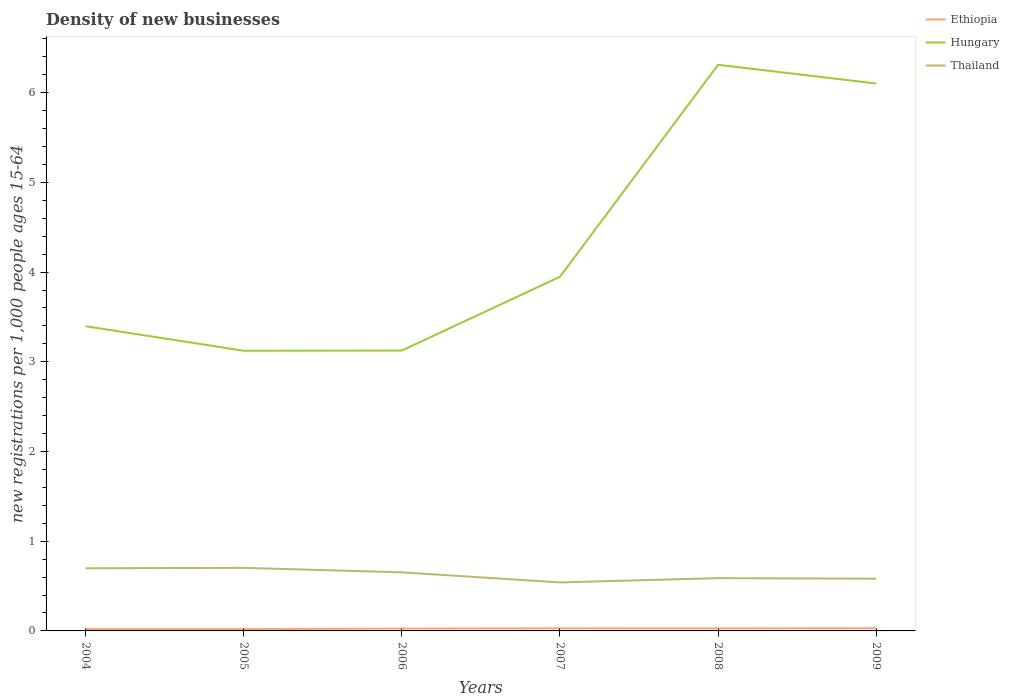Is the number of lines equal to the number of legend labels?
Your response must be concise. Yes. Across all years, what is the maximum number of new registrations in Ethiopia?
Ensure brevity in your answer.  0.02. In which year was the number of new registrations in Hungary maximum?
Provide a short and direct response. 2005. What is the total number of new registrations in Thailand in the graph?
Provide a succinct answer. 0.16. What is the difference between the highest and the second highest number of new registrations in Hungary?
Keep it short and to the point. 3.19. What is the difference between the highest and the lowest number of new registrations in Ethiopia?
Your answer should be very brief. 4. What is the difference between two consecutive major ticks on the Y-axis?
Your answer should be compact. 1. Where does the legend appear in the graph?
Make the answer very short. Top right. What is the title of the graph?
Offer a terse response. Density of new businesses. Does "Luxembourg" appear as one of the legend labels in the graph?
Give a very brief answer. No. What is the label or title of the Y-axis?
Your answer should be compact. New registrations per 1,0 people ages 15-64. What is the new registrations per 1,000 people ages 15-64 of Ethiopia in 2004?
Your answer should be very brief. 0.02. What is the new registrations per 1,000 people ages 15-64 of Hungary in 2004?
Give a very brief answer. 3.4. What is the new registrations per 1,000 people ages 15-64 in Thailand in 2004?
Offer a terse response. 0.7. What is the new registrations per 1,000 people ages 15-64 of Ethiopia in 2005?
Provide a short and direct response. 0.02. What is the new registrations per 1,000 people ages 15-64 of Hungary in 2005?
Provide a succinct answer. 3.12. What is the new registrations per 1,000 people ages 15-64 of Thailand in 2005?
Offer a very short reply. 0.7. What is the new registrations per 1,000 people ages 15-64 of Ethiopia in 2006?
Ensure brevity in your answer.  0.03. What is the new registrations per 1,000 people ages 15-64 in Hungary in 2006?
Give a very brief answer. 3.13. What is the new registrations per 1,000 people ages 15-64 in Thailand in 2006?
Your answer should be very brief. 0.65. What is the new registrations per 1,000 people ages 15-64 of Ethiopia in 2007?
Ensure brevity in your answer.  0.03. What is the new registrations per 1,000 people ages 15-64 of Hungary in 2007?
Give a very brief answer. 3.95. What is the new registrations per 1,000 people ages 15-64 in Thailand in 2007?
Your answer should be compact. 0.54. What is the new registrations per 1,000 people ages 15-64 in Ethiopia in 2008?
Your answer should be very brief. 0.03. What is the new registrations per 1,000 people ages 15-64 of Hungary in 2008?
Ensure brevity in your answer.  6.31. What is the new registrations per 1,000 people ages 15-64 in Thailand in 2008?
Your answer should be compact. 0.59. What is the new registrations per 1,000 people ages 15-64 in Ethiopia in 2009?
Provide a short and direct response. 0.03. What is the new registrations per 1,000 people ages 15-64 in Hungary in 2009?
Provide a succinct answer. 6.1. What is the new registrations per 1,000 people ages 15-64 in Thailand in 2009?
Your answer should be compact. 0.58. Across all years, what is the maximum new registrations per 1,000 people ages 15-64 in Hungary?
Your answer should be compact. 6.31. Across all years, what is the maximum new registrations per 1,000 people ages 15-64 of Thailand?
Offer a very short reply. 0.7. Across all years, what is the minimum new registrations per 1,000 people ages 15-64 in Ethiopia?
Provide a succinct answer. 0.02. Across all years, what is the minimum new registrations per 1,000 people ages 15-64 of Hungary?
Your answer should be very brief. 3.12. Across all years, what is the minimum new registrations per 1,000 people ages 15-64 of Thailand?
Provide a short and direct response. 0.54. What is the total new registrations per 1,000 people ages 15-64 in Ethiopia in the graph?
Ensure brevity in your answer.  0.15. What is the total new registrations per 1,000 people ages 15-64 in Hungary in the graph?
Your answer should be very brief. 26.01. What is the total new registrations per 1,000 people ages 15-64 of Thailand in the graph?
Your response must be concise. 3.77. What is the difference between the new registrations per 1,000 people ages 15-64 in Ethiopia in 2004 and that in 2005?
Your answer should be very brief. -0. What is the difference between the new registrations per 1,000 people ages 15-64 of Hungary in 2004 and that in 2005?
Keep it short and to the point. 0.27. What is the difference between the new registrations per 1,000 people ages 15-64 of Thailand in 2004 and that in 2005?
Provide a short and direct response. -0. What is the difference between the new registrations per 1,000 people ages 15-64 of Ethiopia in 2004 and that in 2006?
Give a very brief answer. -0.01. What is the difference between the new registrations per 1,000 people ages 15-64 in Hungary in 2004 and that in 2006?
Your answer should be very brief. 0.27. What is the difference between the new registrations per 1,000 people ages 15-64 in Thailand in 2004 and that in 2006?
Offer a very short reply. 0.05. What is the difference between the new registrations per 1,000 people ages 15-64 of Ethiopia in 2004 and that in 2007?
Keep it short and to the point. -0.01. What is the difference between the new registrations per 1,000 people ages 15-64 of Hungary in 2004 and that in 2007?
Ensure brevity in your answer.  -0.55. What is the difference between the new registrations per 1,000 people ages 15-64 in Thailand in 2004 and that in 2007?
Your response must be concise. 0.16. What is the difference between the new registrations per 1,000 people ages 15-64 in Ethiopia in 2004 and that in 2008?
Your answer should be compact. -0.01. What is the difference between the new registrations per 1,000 people ages 15-64 of Hungary in 2004 and that in 2008?
Give a very brief answer. -2.91. What is the difference between the new registrations per 1,000 people ages 15-64 of Thailand in 2004 and that in 2008?
Provide a succinct answer. 0.11. What is the difference between the new registrations per 1,000 people ages 15-64 in Ethiopia in 2004 and that in 2009?
Provide a short and direct response. -0.01. What is the difference between the new registrations per 1,000 people ages 15-64 of Hungary in 2004 and that in 2009?
Your response must be concise. -2.71. What is the difference between the new registrations per 1,000 people ages 15-64 in Thailand in 2004 and that in 2009?
Offer a very short reply. 0.12. What is the difference between the new registrations per 1,000 people ages 15-64 of Ethiopia in 2005 and that in 2006?
Offer a very short reply. -0.01. What is the difference between the new registrations per 1,000 people ages 15-64 in Hungary in 2005 and that in 2006?
Provide a succinct answer. -0. What is the difference between the new registrations per 1,000 people ages 15-64 in Thailand in 2005 and that in 2006?
Make the answer very short. 0.05. What is the difference between the new registrations per 1,000 people ages 15-64 in Ethiopia in 2005 and that in 2007?
Your answer should be very brief. -0.01. What is the difference between the new registrations per 1,000 people ages 15-64 of Hungary in 2005 and that in 2007?
Keep it short and to the point. -0.82. What is the difference between the new registrations per 1,000 people ages 15-64 in Thailand in 2005 and that in 2007?
Give a very brief answer. 0.16. What is the difference between the new registrations per 1,000 people ages 15-64 of Ethiopia in 2005 and that in 2008?
Give a very brief answer. -0.01. What is the difference between the new registrations per 1,000 people ages 15-64 in Hungary in 2005 and that in 2008?
Offer a very short reply. -3.19. What is the difference between the new registrations per 1,000 people ages 15-64 of Thailand in 2005 and that in 2008?
Ensure brevity in your answer.  0.11. What is the difference between the new registrations per 1,000 people ages 15-64 in Ethiopia in 2005 and that in 2009?
Your answer should be very brief. -0.01. What is the difference between the new registrations per 1,000 people ages 15-64 of Hungary in 2005 and that in 2009?
Offer a terse response. -2.98. What is the difference between the new registrations per 1,000 people ages 15-64 in Thailand in 2005 and that in 2009?
Ensure brevity in your answer.  0.12. What is the difference between the new registrations per 1,000 people ages 15-64 of Ethiopia in 2006 and that in 2007?
Keep it short and to the point. -0. What is the difference between the new registrations per 1,000 people ages 15-64 in Hungary in 2006 and that in 2007?
Give a very brief answer. -0.82. What is the difference between the new registrations per 1,000 people ages 15-64 of Thailand in 2006 and that in 2007?
Your response must be concise. 0.11. What is the difference between the new registrations per 1,000 people ages 15-64 of Ethiopia in 2006 and that in 2008?
Give a very brief answer. -0. What is the difference between the new registrations per 1,000 people ages 15-64 of Hungary in 2006 and that in 2008?
Make the answer very short. -3.19. What is the difference between the new registrations per 1,000 people ages 15-64 of Thailand in 2006 and that in 2008?
Keep it short and to the point. 0.06. What is the difference between the new registrations per 1,000 people ages 15-64 of Ethiopia in 2006 and that in 2009?
Your answer should be compact. -0. What is the difference between the new registrations per 1,000 people ages 15-64 of Hungary in 2006 and that in 2009?
Offer a terse response. -2.98. What is the difference between the new registrations per 1,000 people ages 15-64 in Thailand in 2006 and that in 2009?
Your answer should be compact. 0.07. What is the difference between the new registrations per 1,000 people ages 15-64 in Ethiopia in 2007 and that in 2008?
Your answer should be compact. 0. What is the difference between the new registrations per 1,000 people ages 15-64 of Hungary in 2007 and that in 2008?
Your response must be concise. -2.36. What is the difference between the new registrations per 1,000 people ages 15-64 of Thailand in 2007 and that in 2008?
Give a very brief answer. -0.05. What is the difference between the new registrations per 1,000 people ages 15-64 of Ethiopia in 2007 and that in 2009?
Offer a very short reply. -0. What is the difference between the new registrations per 1,000 people ages 15-64 in Hungary in 2007 and that in 2009?
Ensure brevity in your answer.  -2.15. What is the difference between the new registrations per 1,000 people ages 15-64 in Thailand in 2007 and that in 2009?
Your answer should be compact. -0.04. What is the difference between the new registrations per 1,000 people ages 15-64 in Ethiopia in 2008 and that in 2009?
Keep it short and to the point. -0. What is the difference between the new registrations per 1,000 people ages 15-64 in Hungary in 2008 and that in 2009?
Your answer should be very brief. 0.21. What is the difference between the new registrations per 1,000 people ages 15-64 of Thailand in 2008 and that in 2009?
Your response must be concise. 0.01. What is the difference between the new registrations per 1,000 people ages 15-64 in Ethiopia in 2004 and the new registrations per 1,000 people ages 15-64 in Hungary in 2005?
Provide a short and direct response. -3.1. What is the difference between the new registrations per 1,000 people ages 15-64 of Ethiopia in 2004 and the new registrations per 1,000 people ages 15-64 of Thailand in 2005?
Offer a very short reply. -0.68. What is the difference between the new registrations per 1,000 people ages 15-64 of Hungary in 2004 and the new registrations per 1,000 people ages 15-64 of Thailand in 2005?
Your response must be concise. 2.69. What is the difference between the new registrations per 1,000 people ages 15-64 of Ethiopia in 2004 and the new registrations per 1,000 people ages 15-64 of Hungary in 2006?
Provide a succinct answer. -3.11. What is the difference between the new registrations per 1,000 people ages 15-64 in Ethiopia in 2004 and the new registrations per 1,000 people ages 15-64 in Thailand in 2006?
Your answer should be very brief. -0.63. What is the difference between the new registrations per 1,000 people ages 15-64 of Hungary in 2004 and the new registrations per 1,000 people ages 15-64 of Thailand in 2006?
Your answer should be compact. 2.74. What is the difference between the new registrations per 1,000 people ages 15-64 in Ethiopia in 2004 and the new registrations per 1,000 people ages 15-64 in Hungary in 2007?
Provide a succinct answer. -3.93. What is the difference between the new registrations per 1,000 people ages 15-64 in Ethiopia in 2004 and the new registrations per 1,000 people ages 15-64 in Thailand in 2007?
Your answer should be very brief. -0.52. What is the difference between the new registrations per 1,000 people ages 15-64 in Hungary in 2004 and the new registrations per 1,000 people ages 15-64 in Thailand in 2007?
Your answer should be very brief. 2.86. What is the difference between the new registrations per 1,000 people ages 15-64 of Ethiopia in 2004 and the new registrations per 1,000 people ages 15-64 of Hungary in 2008?
Ensure brevity in your answer.  -6.29. What is the difference between the new registrations per 1,000 people ages 15-64 of Ethiopia in 2004 and the new registrations per 1,000 people ages 15-64 of Thailand in 2008?
Offer a very short reply. -0.57. What is the difference between the new registrations per 1,000 people ages 15-64 in Hungary in 2004 and the new registrations per 1,000 people ages 15-64 in Thailand in 2008?
Your response must be concise. 2.81. What is the difference between the new registrations per 1,000 people ages 15-64 in Ethiopia in 2004 and the new registrations per 1,000 people ages 15-64 in Hungary in 2009?
Give a very brief answer. -6.08. What is the difference between the new registrations per 1,000 people ages 15-64 in Ethiopia in 2004 and the new registrations per 1,000 people ages 15-64 in Thailand in 2009?
Give a very brief answer. -0.56. What is the difference between the new registrations per 1,000 people ages 15-64 in Hungary in 2004 and the new registrations per 1,000 people ages 15-64 in Thailand in 2009?
Give a very brief answer. 2.81. What is the difference between the new registrations per 1,000 people ages 15-64 in Ethiopia in 2005 and the new registrations per 1,000 people ages 15-64 in Hungary in 2006?
Offer a very short reply. -3.11. What is the difference between the new registrations per 1,000 people ages 15-64 of Ethiopia in 2005 and the new registrations per 1,000 people ages 15-64 of Thailand in 2006?
Your response must be concise. -0.63. What is the difference between the new registrations per 1,000 people ages 15-64 in Hungary in 2005 and the new registrations per 1,000 people ages 15-64 in Thailand in 2006?
Provide a short and direct response. 2.47. What is the difference between the new registrations per 1,000 people ages 15-64 in Ethiopia in 2005 and the new registrations per 1,000 people ages 15-64 in Hungary in 2007?
Provide a short and direct response. -3.93. What is the difference between the new registrations per 1,000 people ages 15-64 of Ethiopia in 2005 and the new registrations per 1,000 people ages 15-64 of Thailand in 2007?
Ensure brevity in your answer.  -0.52. What is the difference between the new registrations per 1,000 people ages 15-64 in Hungary in 2005 and the new registrations per 1,000 people ages 15-64 in Thailand in 2007?
Give a very brief answer. 2.58. What is the difference between the new registrations per 1,000 people ages 15-64 in Ethiopia in 2005 and the new registrations per 1,000 people ages 15-64 in Hungary in 2008?
Ensure brevity in your answer.  -6.29. What is the difference between the new registrations per 1,000 people ages 15-64 of Ethiopia in 2005 and the new registrations per 1,000 people ages 15-64 of Thailand in 2008?
Offer a very short reply. -0.57. What is the difference between the new registrations per 1,000 people ages 15-64 of Hungary in 2005 and the new registrations per 1,000 people ages 15-64 of Thailand in 2008?
Make the answer very short. 2.54. What is the difference between the new registrations per 1,000 people ages 15-64 of Ethiopia in 2005 and the new registrations per 1,000 people ages 15-64 of Hungary in 2009?
Keep it short and to the point. -6.08. What is the difference between the new registrations per 1,000 people ages 15-64 of Ethiopia in 2005 and the new registrations per 1,000 people ages 15-64 of Thailand in 2009?
Give a very brief answer. -0.56. What is the difference between the new registrations per 1,000 people ages 15-64 of Hungary in 2005 and the new registrations per 1,000 people ages 15-64 of Thailand in 2009?
Offer a terse response. 2.54. What is the difference between the new registrations per 1,000 people ages 15-64 in Ethiopia in 2006 and the new registrations per 1,000 people ages 15-64 in Hungary in 2007?
Your answer should be compact. -3.92. What is the difference between the new registrations per 1,000 people ages 15-64 of Ethiopia in 2006 and the new registrations per 1,000 people ages 15-64 of Thailand in 2007?
Your answer should be very brief. -0.51. What is the difference between the new registrations per 1,000 people ages 15-64 of Hungary in 2006 and the new registrations per 1,000 people ages 15-64 of Thailand in 2007?
Offer a very short reply. 2.58. What is the difference between the new registrations per 1,000 people ages 15-64 of Ethiopia in 2006 and the new registrations per 1,000 people ages 15-64 of Hungary in 2008?
Your response must be concise. -6.29. What is the difference between the new registrations per 1,000 people ages 15-64 in Ethiopia in 2006 and the new registrations per 1,000 people ages 15-64 in Thailand in 2008?
Your response must be concise. -0.56. What is the difference between the new registrations per 1,000 people ages 15-64 in Hungary in 2006 and the new registrations per 1,000 people ages 15-64 in Thailand in 2008?
Ensure brevity in your answer.  2.54. What is the difference between the new registrations per 1,000 people ages 15-64 in Ethiopia in 2006 and the new registrations per 1,000 people ages 15-64 in Hungary in 2009?
Keep it short and to the point. -6.08. What is the difference between the new registrations per 1,000 people ages 15-64 in Ethiopia in 2006 and the new registrations per 1,000 people ages 15-64 in Thailand in 2009?
Make the answer very short. -0.56. What is the difference between the new registrations per 1,000 people ages 15-64 in Hungary in 2006 and the new registrations per 1,000 people ages 15-64 in Thailand in 2009?
Give a very brief answer. 2.54. What is the difference between the new registrations per 1,000 people ages 15-64 of Ethiopia in 2007 and the new registrations per 1,000 people ages 15-64 of Hungary in 2008?
Your response must be concise. -6.28. What is the difference between the new registrations per 1,000 people ages 15-64 of Ethiopia in 2007 and the new registrations per 1,000 people ages 15-64 of Thailand in 2008?
Offer a terse response. -0.56. What is the difference between the new registrations per 1,000 people ages 15-64 in Hungary in 2007 and the new registrations per 1,000 people ages 15-64 in Thailand in 2008?
Give a very brief answer. 3.36. What is the difference between the new registrations per 1,000 people ages 15-64 of Ethiopia in 2007 and the new registrations per 1,000 people ages 15-64 of Hungary in 2009?
Ensure brevity in your answer.  -6.07. What is the difference between the new registrations per 1,000 people ages 15-64 of Ethiopia in 2007 and the new registrations per 1,000 people ages 15-64 of Thailand in 2009?
Provide a short and direct response. -0.55. What is the difference between the new registrations per 1,000 people ages 15-64 of Hungary in 2007 and the new registrations per 1,000 people ages 15-64 of Thailand in 2009?
Your response must be concise. 3.37. What is the difference between the new registrations per 1,000 people ages 15-64 in Ethiopia in 2008 and the new registrations per 1,000 people ages 15-64 in Hungary in 2009?
Your answer should be compact. -6.07. What is the difference between the new registrations per 1,000 people ages 15-64 in Ethiopia in 2008 and the new registrations per 1,000 people ages 15-64 in Thailand in 2009?
Give a very brief answer. -0.55. What is the difference between the new registrations per 1,000 people ages 15-64 of Hungary in 2008 and the new registrations per 1,000 people ages 15-64 of Thailand in 2009?
Give a very brief answer. 5.73. What is the average new registrations per 1,000 people ages 15-64 in Ethiopia per year?
Make the answer very short. 0.03. What is the average new registrations per 1,000 people ages 15-64 in Hungary per year?
Keep it short and to the point. 4.33. What is the average new registrations per 1,000 people ages 15-64 in Thailand per year?
Provide a short and direct response. 0.63. In the year 2004, what is the difference between the new registrations per 1,000 people ages 15-64 in Ethiopia and new registrations per 1,000 people ages 15-64 in Hungary?
Provide a short and direct response. -3.38. In the year 2004, what is the difference between the new registrations per 1,000 people ages 15-64 in Ethiopia and new registrations per 1,000 people ages 15-64 in Thailand?
Provide a short and direct response. -0.68. In the year 2004, what is the difference between the new registrations per 1,000 people ages 15-64 of Hungary and new registrations per 1,000 people ages 15-64 of Thailand?
Provide a short and direct response. 2.7. In the year 2005, what is the difference between the new registrations per 1,000 people ages 15-64 of Ethiopia and new registrations per 1,000 people ages 15-64 of Hungary?
Ensure brevity in your answer.  -3.1. In the year 2005, what is the difference between the new registrations per 1,000 people ages 15-64 of Ethiopia and new registrations per 1,000 people ages 15-64 of Thailand?
Keep it short and to the point. -0.68. In the year 2005, what is the difference between the new registrations per 1,000 people ages 15-64 of Hungary and new registrations per 1,000 people ages 15-64 of Thailand?
Your answer should be compact. 2.42. In the year 2006, what is the difference between the new registrations per 1,000 people ages 15-64 in Ethiopia and new registrations per 1,000 people ages 15-64 in Hungary?
Provide a short and direct response. -3.1. In the year 2006, what is the difference between the new registrations per 1,000 people ages 15-64 of Ethiopia and new registrations per 1,000 people ages 15-64 of Thailand?
Provide a succinct answer. -0.63. In the year 2006, what is the difference between the new registrations per 1,000 people ages 15-64 of Hungary and new registrations per 1,000 people ages 15-64 of Thailand?
Your response must be concise. 2.47. In the year 2007, what is the difference between the new registrations per 1,000 people ages 15-64 of Ethiopia and new registrations per 1,000 people ages 15-64 of Hungary?
Your answer should be compact. -3.92. In the year 2007, what is the difference between the new registrations per 1,000 people ages 15-64 in Ethiopia and new registrations per 1,000 people ages 15-64 in Thailand?
Provide a succinct answer. -0.51. In the year 2007, what is the difference between the new registrations per 1,000 people ages 15-64 in Hungary and new registrations per 1,000 people ages 15-64 in Thailand?
Your answer should be compact. 3.41. In the year 2008, what is the difference between the new registrations per 1,000 people ages 15-64 in Ethiopia and new registrations per 1,000 people ages 15-64 in Hungary?
Offer a very short reply. -6.28. In the year 2008, what is the difference between the new registrations per 1,000 people ages 15-64 of Ethiopia and new registrations per 1,000 people ages 15-64 of Thailand?
Make the answer very short. -0.56. In the year 2008, what is the difference between the new registrations per 1,000 people ages 15-64 in Hungary and new registrations per 1,000 people ages 15-64 in Thailand?
Provide a short and direct response. 5.72. In the year 2009, what is the difference between the new registrations per 1,000 people ages 15-64 in Ethiopia and new registrations per 1,000 people ages 15-64 in Hungary?
Make the answer very short. -6.07. In the year 2009, what is the difference between the new registrations per 1,000 people ages 15-64 in Ethiopia and new registrations per 1,000 people ages 15-64 in Thailand?
Make the answer very short. -0.55. In the year 2009, what is the difference between the new registrations per 1,000 people ages 15-64 of Hungary and new registrations per 1,000 people ages 15-64 of Thailand?
Offer a very short reply. 5.52. What is the ratio of the new registrations per 1,000 people ages 15-64 of Hungary in 2004 to that in 2005?
Your answer should be very brief. 1.09. What is the ratio of the new registrations per 1,000 people ages 15-64 of Thailand in 2004 to that in 2005?
Ensure brevity in your answer.  0.99. What is the ratio of the new registrations per 1,000 people ages 15-64 in Ethiopia in 2004 to that in 2006?
Give a very brief answer. 0.77. What is the ratio of the new registrations per 1,000 people ages 15-64 of Hungary in 2004 to that in 2006?
Offer a very short reply. 1.09. What is the ratio of the new registrations per 1,000 people ages 15-64 in Thailand in 2004 to that in 2006?
Provide a short and direct response. 1.07. What is the ratio of the new registrations per 1,000 people ages 15-64 in Ethiopia in 2004 to that in 2007?
Provide a succinct answer. 0.69. What is the ratio of the new registrations per 1,000 people ages 15-64 of Hungary in 2004 to that in 2007?
Offer a terse response. 0.86. What is the ratio of the new registrations per 1,000 people ages 15-64 in Thailand in 2004 to that in 2007?
Your answer should be compact. 1.29. What is the ratio of the new registrations per 1,000 people ages 15-64 of Ethiopia in 2004 to that in 2008?
Offer a very short reply. 0.71. What is the ratio of the new registrations per 1,000 people ages 15-64 in Hungary in 2004 to that in 2008?
Provide a succinct answer. 0.54. What is the ratio of the new registrations per 1,000 people ages 15-64 in Thailand in 2004 to that in 2008?
Offer a very short reply. 1.19. What is the ratio of the new registrations per 1,000 people ages 15-64 in Ethiopia in 2004 to that in 2009?
Your answer should be very brief. 0.67. What is the ratio of the new registrations per 1,000 people ages 15-64 in Hungary in 2004 to that in 2009?
Provide a succinct answer. 0.56. What is the ratio of the new registrations per 1,000 people ages 15-64 in Thailand in 2004 to that in 2009?
Offer a very short reply. 1.2. What is the ratio of the new registrations per 1,000 people ages 15-64 in Ethiopia in 2005 to that in 2006?
Offer a terse response. 0.77. What is the ratio of the new registrations per 1,000 people ages 15-64 of Hungary in 2005 to that in 2006?
Provide a short and direct response. 1. What is the ratio of the new registrations per 1,000 people ages 15-64 of Thailand in 2005 to that in 2006?
Offer a terse response. 1.08. What is the ratio of the new registrations per 1,000 people ages 15-64 of Ethiopia in 2005 to that in 2007?
Offer a very short reply. 0.69. What is the ratio of the new registrations per 1,000 people ages 15-64 of Hungary in 2005 to that in 2007?
Your response must be concise. 0.79. What is the ratio of the new registrations per 1,000 people ages 15-64 of Thailand in 2005 to that in 2007?
Provide a succinct answer. 1.3. What is the ratio of the new registrations per 1,000 people ages 15-64 of Ethiopia in 2005 to that in 2008?
Provide a succinct answer. 0.71. What is the ratio of the new registrations per 1,000 people ages 15-64 in Hungary in 2005 to that in 2008?
Your answer should be very brief. 0.49. What is the ratio of the new registrations per 1,000 people ages 15-64 of Thailand in 2005 to that in 2008?
Offer a terse response. 1.2. What is the ratio of the new registrations per 1,000 people ages 15-64 in Ethiopia in 2005 to that in 2009?
Ensure brevity in your answer.  0.67. What is the ratio of the new registrations per 1,000 people ages 15-64 in Hungary in 2005 to that in 2009?
Provide a succinct answer. 0.51. What is the ratio of the new registrations per 1,000 people ages 15-64 of Thailand in 2005 to that in 2009?
Your answer should be compact. 1.21. What is the ratio of the new registrations per 1,000 people ages 15-64 of Ethiopia in 2006 to that in 2007?
Ensure brevity in your answer.  0.9. What is the ratio of the new registrations per 1,000 people ages 15-64 of Hungary in 2006 to that in 2007?
Provide a succinct answer. 0.79. What is the ratio of the new registrations per 1,000 people ages 15-64 of Thailand in 2006 to that in 2007?
Your answer should be very brief. 1.21. What is the ratio of the new registrations per 1,000 people ages 15-64 in Ethiopia in 2006 to that in 2008?
Provide a short and direct response. 0.91. What is the ratio of the new registrations per 1,000 people ages 15-64 in Hungary in 2006 to that in 2008?
Your answer should be compact. 0.5. What is the ratio of the new registrations per 1,000 people ages 15-64 of Thailand in 2006 to that in 2008?
Make the answer very short. 1.11. What is the ratio of the new registrations per 1,000 people ages 15-64 of Ethiopia in 2006 to that in 2009?
Your answer should be compact. 0.87. What is the ratio of the new registrations per 1,000 people ages 15-64 in Hungary in 2006 to that in 2009?
Provide a short and direct response. 0.51. What is the ratio of the new registrations per 1,000 people ages 15-64 in Thailand in 2006 to that in 2009?
Make the answer very short. 1.12. What is the ratio of the new registrations per 1,000 people ages 15-64 of Ethiopia in 2007 to that in 2008?
Offer a very short reply. 1.02. What is the ratio of the new registrations per 1,000 people ages 15-64 of Hungary in 2007 to that in 2008?
Your answer should be compact. 0.63. What is the ratio of the new registrations per 1,000 people ages 15-64 in Thailand in 2007 to that in 2008?
Your answer should be compact. 0.92. What is the ratio of the new registrations per 1,000 people ages 15-64 of Ethiopia in 2007 to that in 2009?
Provide a short and direct response. 0.97. What is the ratio of the new registrations per 1,000 people ages 15-64 of Hungary in 2007 to that in 2009?
Provide a succinct answer. 0.65. What is the ratio of the new registrations per 1,000 people ages 15-64 of Thailand in 2007 to that in 2009?
Make the answer very short. 0.93. What is the ratio of the new registrations per 1,000 people ages 15-64 of Ethiopia in 2008 to that in 2009?
Provide a short and direct response. 0.95. What is the ratio of the new registrations per 1,000 people ages 15-64 of Hungary in 2008 to that in 2009?
Give a very brief answer. 1.03. What is the ratio of the new registrations per 1,000 people ages 15-64 of Thailand in 2008 to that in 2009?
Provide a short and direct response. 1.01. What is the difference between the highest and the second highest new registrations per 1,000 people ages 15-64 in Hungary?
Provide a short and direct response. 0.21. What is the difference between the highest and the second highest new registrations per 1,000 people ages 15-64 of Thailand?
Ensure brevity in your answer.  0. What is the difference between the highest and the lowest new registrations per 1,000 people ages 15-64 in Ethiopia?
Make the answer very short. 0.01. What is the difference between the highest and the lowest new registrations per 1,000 people ages 15-64 of Hungary?
Provide a short and direct response. 3.19. What is the difference between the highest and the lowest new registrations per 1,000 people ages 15-64 in Thailand?
Offer a terse response. 0.16. 